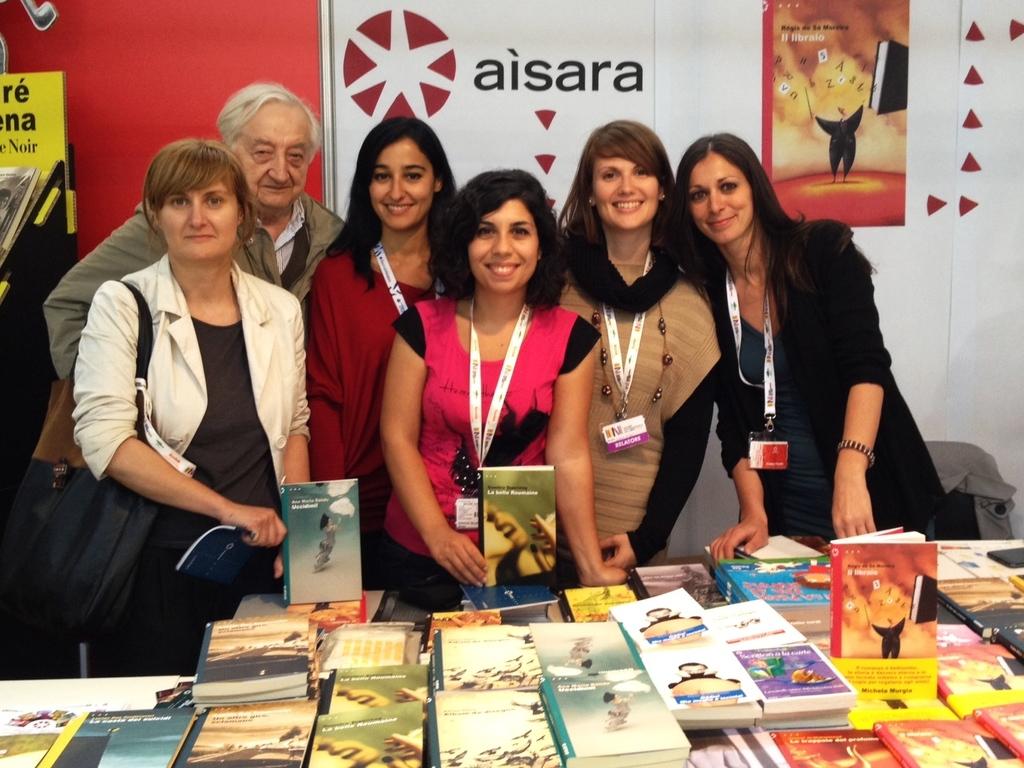What is the title of the book on the poster?
Give a very brief answer. Unanswerable. 